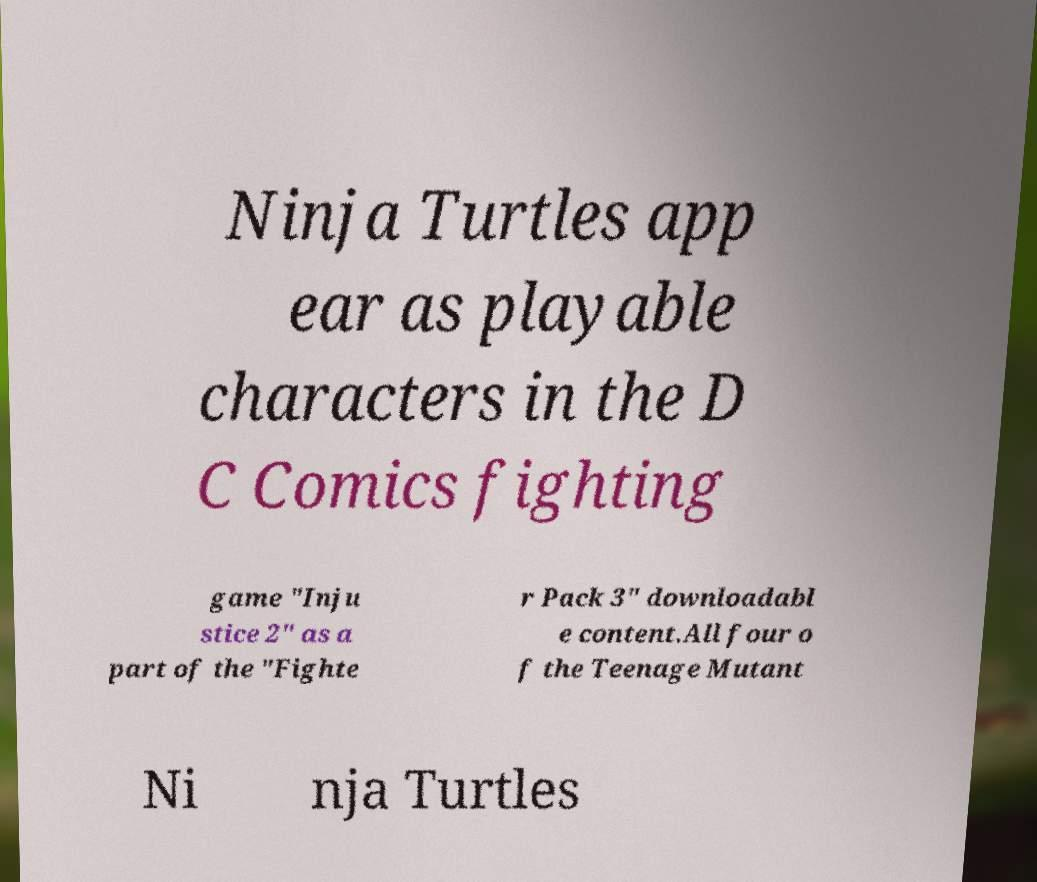There's text embedded in this image that I need extracted. Can you transcribe it verbatim? Ninja Turtles app ear as playable characters in the D C Comics fighting game "Inju stice 2" as a part of the "Fighte r Pack 3" downloadabl e content.All four o f the Teenage Mutant Ni nja Turtles 